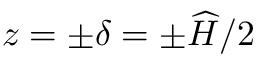Convert formula to latex. <formula><loc_0><loc_0><loc_500><loc_500>z = \pm \delta = \pm \widehat { H } / 2</formula> 